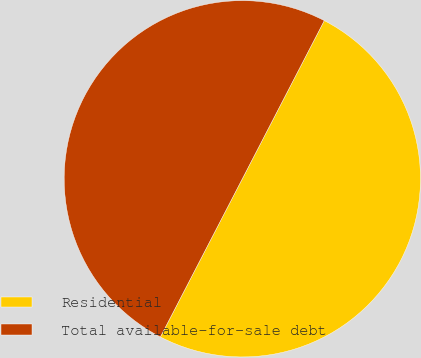Convert chart. <chart><loc_0><loc_0><loc_500><loc_500><pie_chart><fcel>Residential<fcel>Total available-for-sale debt<nl><fcel>50.0%<fcel>50.0%<nl></chart> 